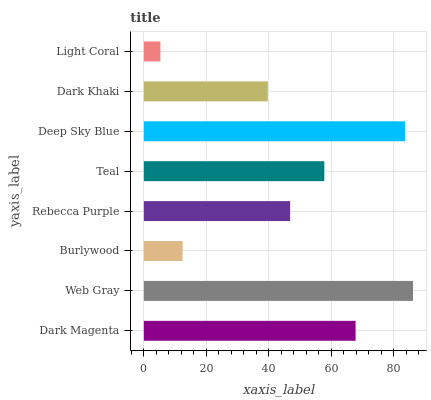Is Light Coral the minimum?
Answer yes or no. Yes. Is Web Gray the maximum?
Answer yes or no. Yes. Is Burlywood the minimum?
Answer yes or no. No. Is Burlywood the maximum?
Answer yes or no. No. Is Web Gray greater than Burlywood?
Answer yes or no. Yes. Is Burlywood less than Web Gray?
Answer yes or no. Yes. Is Burlywood greater than Web Gray?
Answer yes or no. No. Is Web Gray less than Burlywood?
Answer yes or no. No. Is Teal the high median?
Answer yes or no. Yes. Is Rebecca Purple the low median?
Answer yes or no. Yes. Is Deep Sky Blue the high median?
Answer yes or no. No. Is Deep Sky Blue the low median?
Answer yes or no. No. 